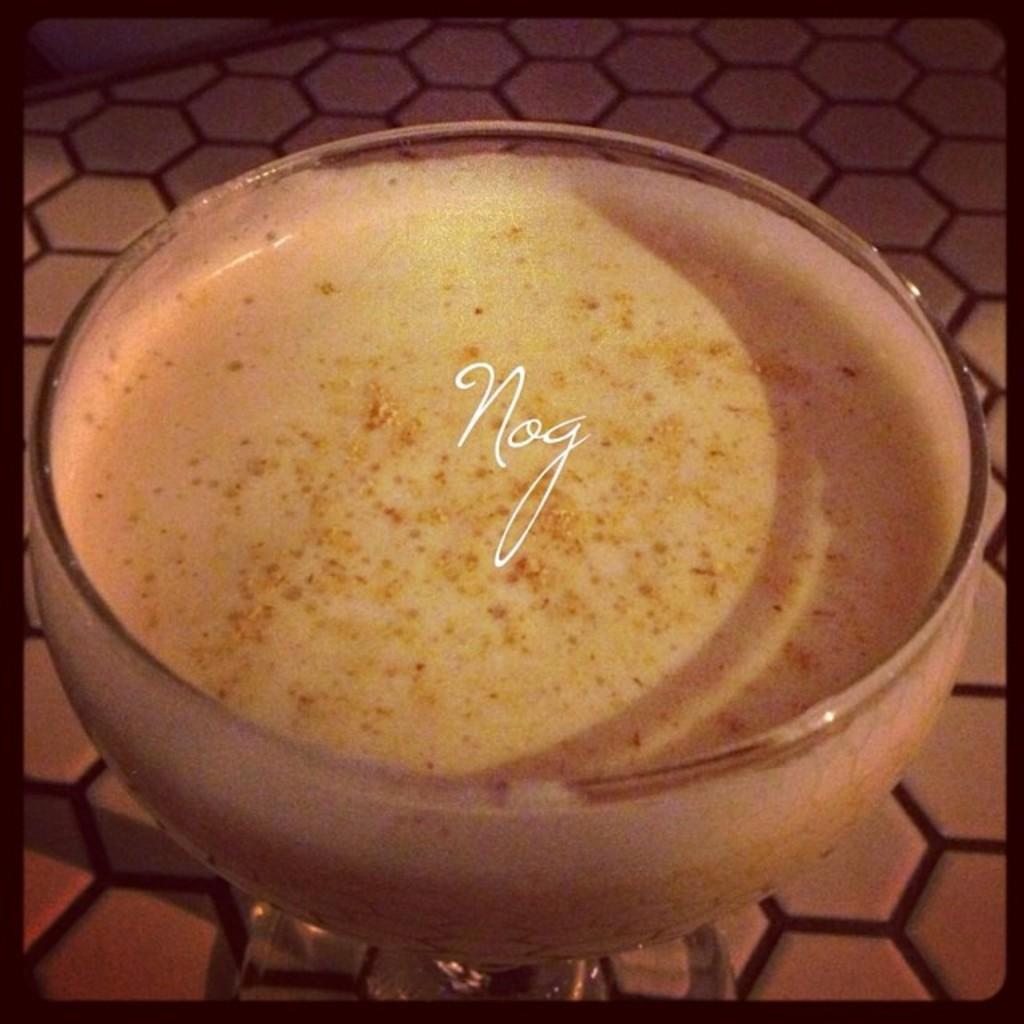How would you summarize this image in a sentence or two? In the image we can see there is a desert cup in which there is a sweet and on it it's written "Nog". 